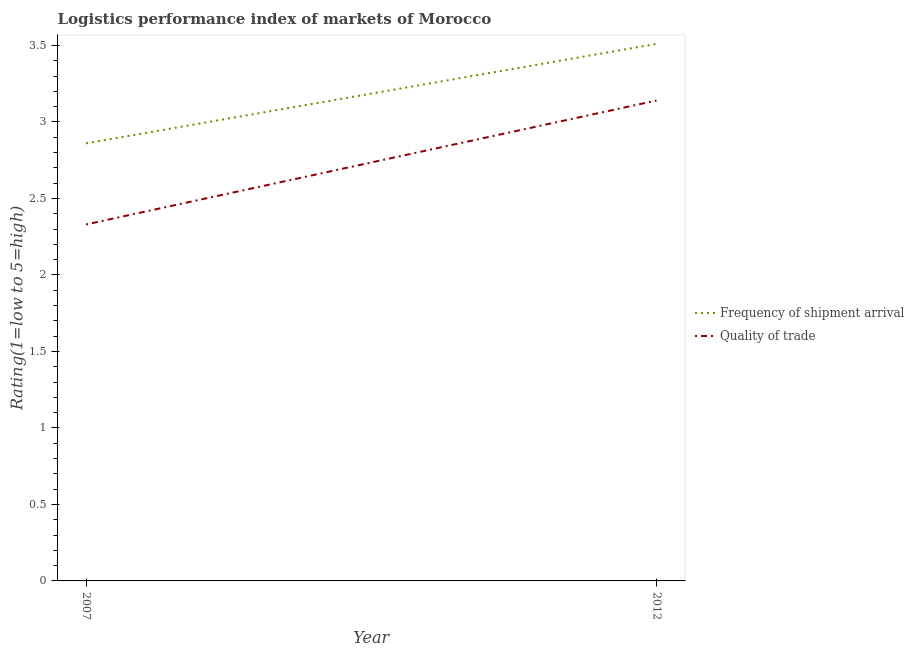How many different coloured lines are there?
Your answer should be very brief. 2. Is the number of lines equal to the number of legend labels?
Offer a terse response. Yes. What is the lpi quality of trade in 2007?
Provide a succinct answer. 2.33. Across all years, what is the maximum lpi of frequency of shipment arrival?
Your answer should be very brief. 3.51. Across all years, what is the minimum lpi quality of trade?
Your answer should be very brief. 2.33. In which year was the lpi of frequency of shipment arrival maximum?
Offer a terse response. 2012. In which year was the lpi of frequency of shipment arrival minimum?
Ensure brevity in your answer.  2007. What is the total lpi of frequency of shipment arrival in the graph?
Offer a terse response. 6.37. What is the difference between the lpi of frequency of shipment arrival in 2007 and that in 2012?
Your answer should be very brief. -0.65. What is the difference between the lpi quality of trade in 2012 and the lpi of frequency of shipment arrival in 2007?
Ensure brevity in your answer.  0.28. What is the average lpi quality of trade per year?
Give a very brief answer. 2.74. In the year 2012, what is the difference between the lpi of frequency of shipment arrival and lpi quality of trade?
Make the answer very short. 0.37. What is the ratio of the lpi quality of trade in 2007 to that in 2012?
Offer a terse response. 0.74. How many lines are there?
Give a very brief answer. 2. How many years are there in the graph?
Offer a very short reply. 2. Does the graph contain any zero values?
Provide a short and direct response. No. Does the graph contain grids?
Keep it short and to the point. No. Where does the legend appear in the graph?
Your answer should be compact. Center right. What is the title of the graph?
Provide a short and direct response. Logistics performance index of markets of Morocco. What is the label or title of the X-axis?
Provide a short and direct response. Year. What is the label or title of the Y-axis?
Make the answer very short. Rating(1=low to 5=high). What is the Rating(1=low to 5=high) in Frequency of shipment arrival in 2007?
Give a very brief answer. 2.86. What is the Rating(1=low to 5=high) of Quality of trade in 2007?
Ensure brevity in your answer.  2.33. What is the Rating(1=low to 5=high) of Frequency of shipment arrival in 2012?
Ensure brevity in your answer.  3.51. What is the Rating(1=low to 5=high) of Quality of trade in 2012?
Provide a succinct answer. 3.14. Across all years, what is the maximum Rating(1=low to 5=high) of Frequency of shipment arrival?
Make the answer very short. 3.51. Across all years, what is the maximum Rating(1=low to 5=high) of Quality of trade?
Your answer should be compact. 3.14. Across all years, what is the minimum Rating(1=low to 5=high) in Frequency of shipment arrival?
Your response must be concise. 2.86. Across all years, what is the minimum Rating(1=low to 5=high) in Quality of trade?
Provide a succinct answer. 2.33. What is the total Rating(1=low to 5=high) of Frequency of shipment arrival in the graph?
Your answer should be very brief. 6.37. What is the total Rating(1=low to 5=high) in Quality of trade in the graph?
Provide a succinct answer. 5.47. What is the difference between the Rating(1=low to 5=high) of Frequency of shipment arrival in 2007 and that in 2012?
Provide a short and direct response. -0.65. What is the difference between the Rating(1=low to 5=high) in Quality of trade in 2007 and that in 2012?
Your response must be concise. -0.81. What is the difference between the Rating(1=low to 5=high) in Frequency of shipment arrival in 2007 and the Rating(1=low to 5=high) in Quality of trade in 2012?
Offer a very short reply. -0.28. What is the average Rating(1=low to 5=high) in Frequency of shipment arrival per year?
Offer a terse response. 3.19. What is the average Rating(1=low to 5=high) in Quality of trade per year?
Make the answer very short. 2.73. In the year 2007, what is the difference between the Rating(1=low to 5=high) in Frequency of shipment arrival and Rating(1=low to 5=high) in Quality of trade?
Offer a terse response. 0.53. In the year 2012, what is the difference between the Rating(1=low to 5=high) in Frequency of shipment arrival and Rating(1=low to 5=high) in Quality of trade?
Your response must be concise. 0.37. What is the ratio of the Rating(1=low to 5=high) in Frequency of shipment arrival in 2007 to that in 2012?
Provide a succinct answer. 0.81. What is the ratio of the Rating(1=low to 5=high) in Quality of trade in 2007 to that in 2012?
Make the answer very short. 0.74. What is the difference between the highest and the second highest Rating(1=low to 5=high) in Frequency of shipment arrival?
Your answer should be very brief. 0.65. What is the difference between the highest and the second highest Rating(1=low to 5=high) of Quality of trade?
Make the answer very short. 0.81. What is the difference between the highest and the lowest Rating(1=low to 5=high) in Frequency of shipment arrival?
Offer a very short reply. 0.65. What is the difference between the highest and the lowest Rating(1=low to 5=high) in Quality of trade?
Offer a terse response. 0.81. 